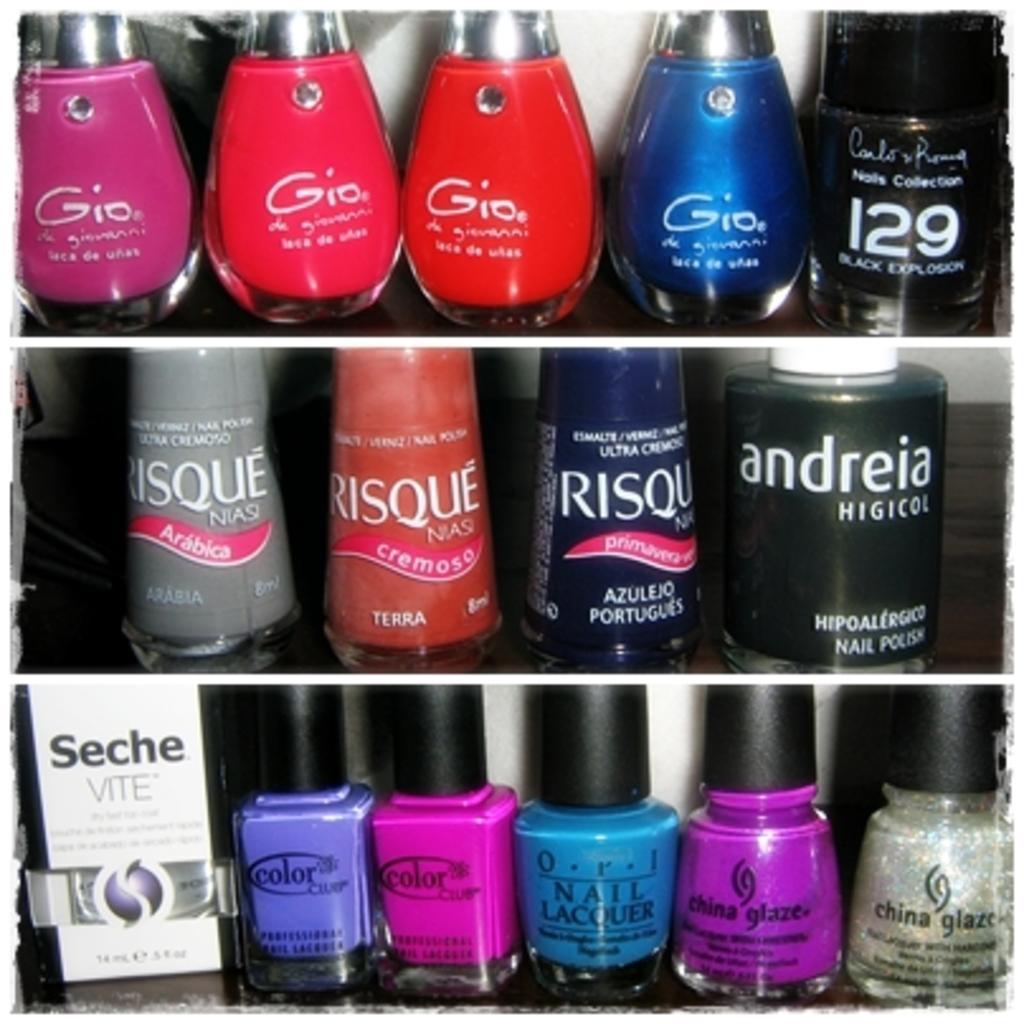Please provide a concise description of this image. In this image we can see a few bottles inside the shelf and text written on the bottles. 